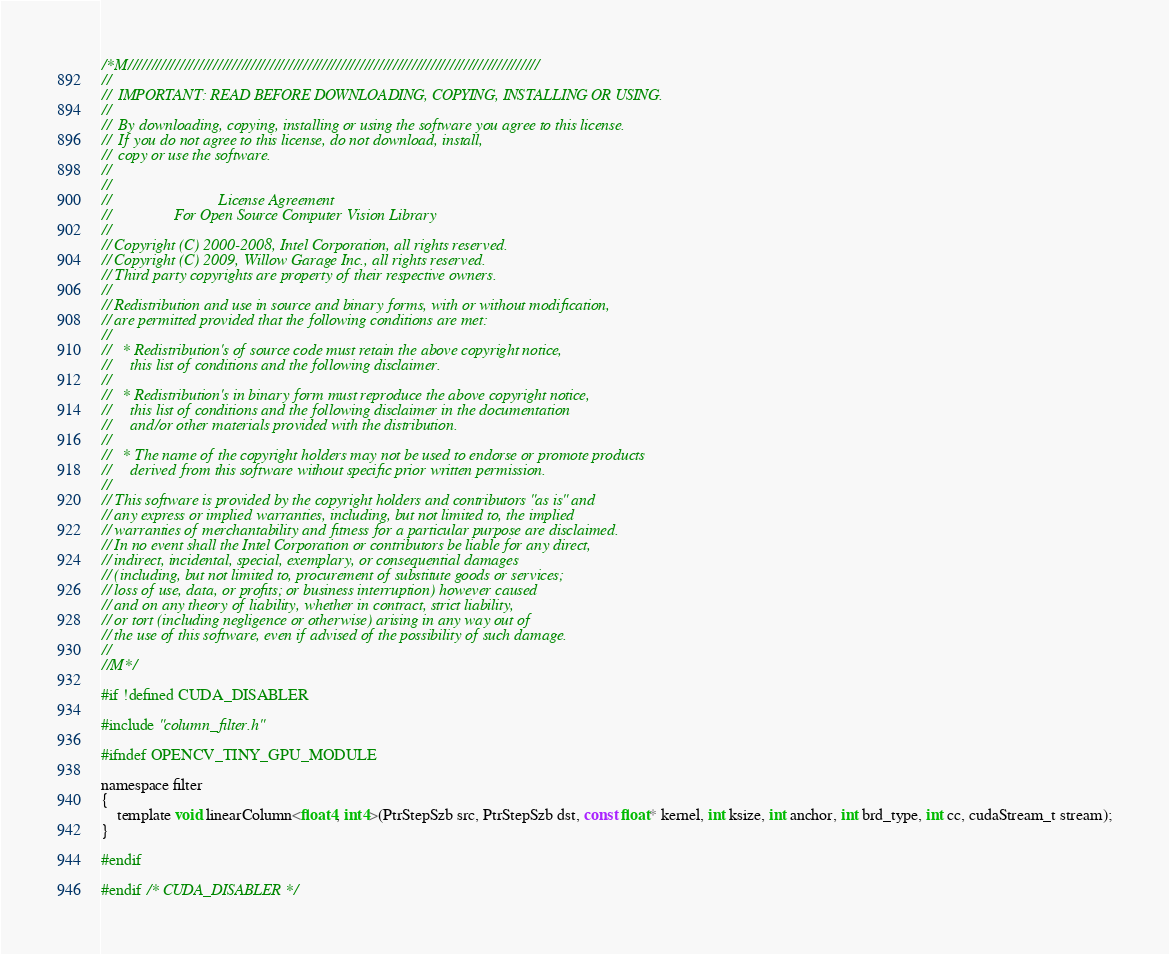Convert code to text. <code><loc_0><loc_0><loc_500><loc_500><_Cuda_>/*M///////////////////////////////////////////////////////////////////////////////////////
//
//  IMPORTANT: READ BEFORE DOWNLOADING, COPYING, INSTALLING OR USING.
//
//  By downloading, copying, installing or using the software you agree to this license.
//  If you do not agree to this license, do not download, install,
//  copy or use the software.
//
//
//                           License Agreement
//                For Open Source Computer Vision Library
//
// Copyright (C) 2000-2008, Intel Corporation, all rights reserved.
// Copyright (C) 2009, Willow Garage Inc., all rights reserved.
// Third party copyrights are property of their respective owners.
//
// Redistribution and use in source and binary forms, with or without modification,
// are permitted provided that the following conditions are met:
//
//   * Redistribution's of source code must retain the above copyright notice,
//     this list of conditions and the following disclaimer.
//
//   * Redistribution's in binary form must reproduce the above copyright notice,
//     this list of conditions and the following disclaimer in the documentation
//     and/or other materials provided with the distribution.
//
//   * The name of the copyright holders may not be used to endorse or promote products
//     derived from this software without specific prior written permission.
//
// This software is provided by the copyright holders and contributors "as is" and
// any express or implied warranties, including, but not limited to, the implied
// warranties of merchantability and fitness for a particular purpose are disclaimed.
// In no event shall the Intel Corporation or contributors be liable for any direct,
// indirect, incidental, special, exemplary, or consequential damages
// (including, but not limited to, procurement of substitute goods or services;
// loss of use, data, or profits; or business interruption) however caused
// and on any theory of liability, whether in contract, strict liability,
// or tort (including negligence or otherwise) arising in any way out of
// the use of this software, even if advised of the possibility of such damage.
//
//M*/

#if !defined CUDA_DISABLER

#include "column_filter.h"

#ifndef OPENCV_TINY_GPU_MODULE

namespace filter
{
    template void linearColumn<float4, int4>(PtrStepSzb src, PtrStepSzb dst, const float* kernel, int ksize, int anchor, int brd_type, int cc, cudaStream_t stream);
}

#endif

#endif /* CUDA_DISABLER */
</code> 